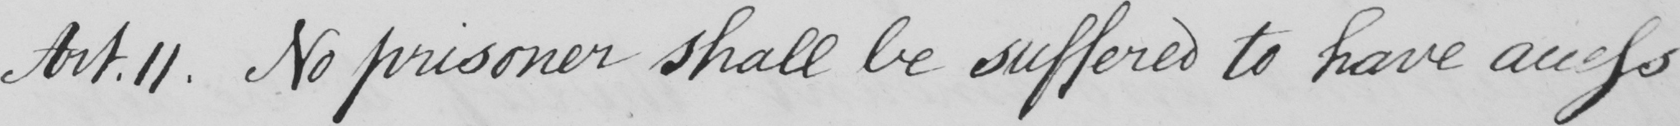Please transcribe the handwritten text in this image. Art.11. No prisoner shall be suffered to have access 